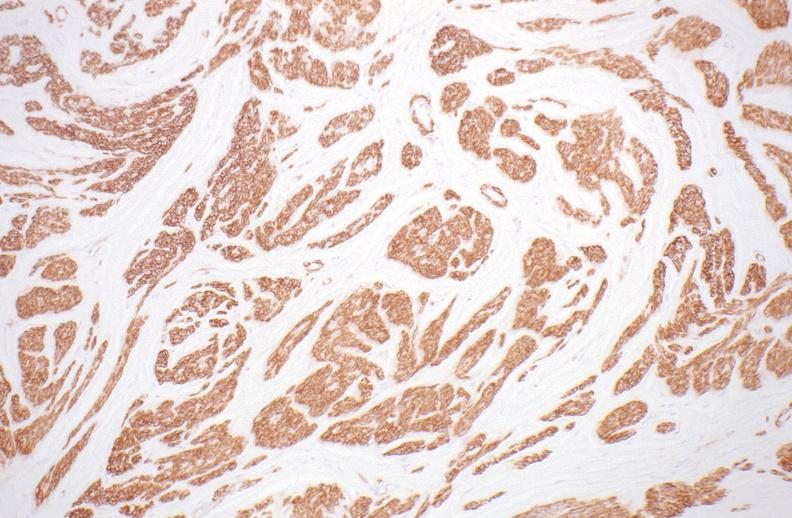does normal immature infant show leiomyoma?
Answer the question using a single word or phrase. No 